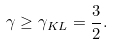<formula> <loc_0><loc_0><loc_500><loc_500>\gamma \geq \gamma _ { K L } = \frac { 3 } { 2 } .</formula> 